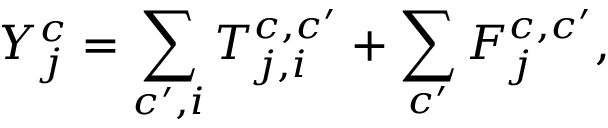<formula> <loc_0><loc_0><loc_500><loc_500>Y _ { j } ^ { c } = \sum _ { c ^ { \prime } , i } T _ { j , i } ^ { c , c ^ { \prime } } + \sum _ { c ^ { \prime } } F _ { j } ^ { c , c ^ { \prime } } ,</formula> 